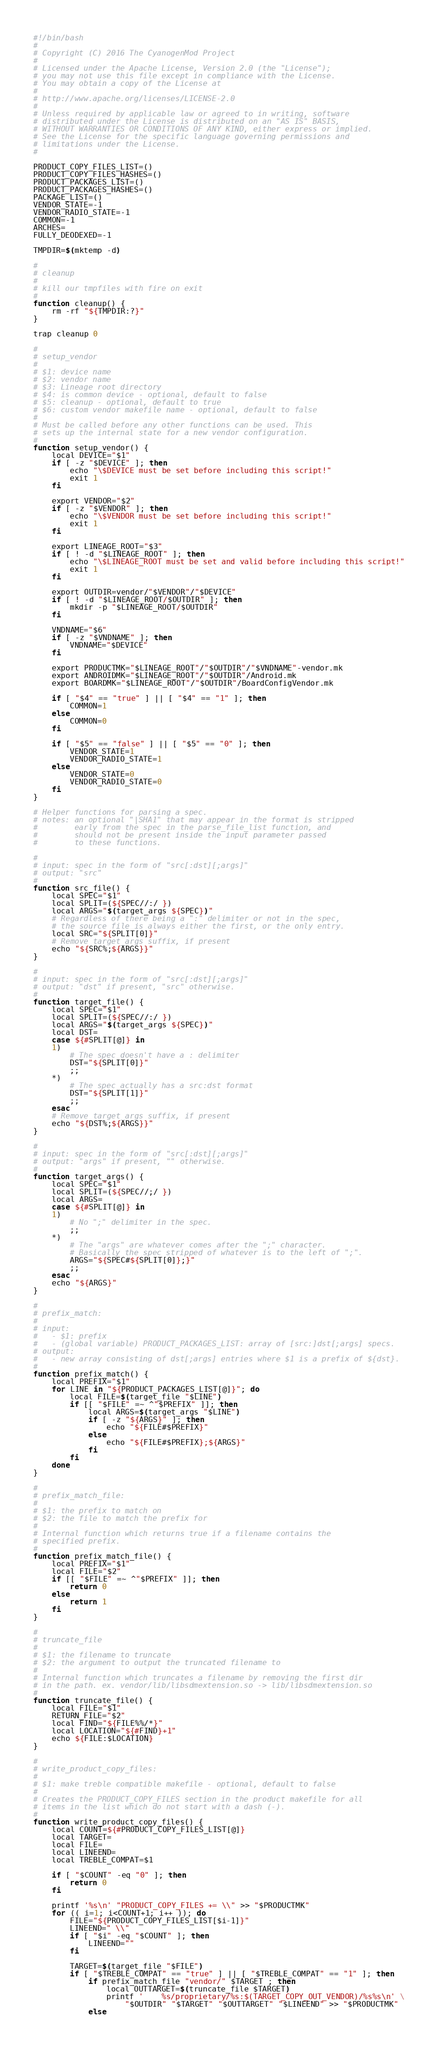<code> <loc_0><loc_0><loc_500><loc_500><_Bash_>#!/bin/bash
#
# Copyright (C) 2016 The CyanogenMod Project
#
# Licensed under the Apache License, Version 2.0 (the "License");
# you may not use this file except in compliance with the License.
# You may obtain a copy of the License at
#
# http://www.apache.org/licenses/LICENSE-2.0
#
# Unless required by applicable law or agreed to in writing, software
# distributed under the License is distributed on an "AS IS" BASIS,
# WITHOUT WARRANTIES OR CONDITIONS OF ANY KIND, either express or implied.
# See the License for the specific language governing permissions and
# limitations under the License.
#

PRODUCT_COPY_FILES_LIST=()
PRODUCT_COPY_FILES_HASHES=()
PRODUCT_PACKAGES_LIST=()
PRODUCT_PACKAGES_HASHES=()
PACKAGE_LIST=()
VENDOR_STATE=-1
VENDOR_RADIO_STATE=-1
COMMON=-1
ARCHES=
FULLY_DEODEXED=-1

TMPDIR=$(mktemp -d)

#
# cleanup
#
# kill our tmpfiles with fire on exit
#
function cleanup() {
    rm -rf "${TMPDIR:?}"
}

trap cleanup 0

#
# setup_vendor
#
# $1: device name
# $2: vendor name
# $3: Lineage root directory
# $4: is common device - optional, default to false
# $5: cleanup - optional, default to true
# $6: custom vendor makefile name - optional, default to false
#
# Must be called before any other functions can be used. This
# sets up the internal state for a new vendor configuration.
#
function setup_vendor() {
    local DEVICE="$1"
    if [ -z "$DEVICE" ]; then
        echo "\$DEVICE must be set before including this script!"
        exit 1
    fi

    export VENDOR="$2"
    if [ -z "$VENDOR" ]; then
        echo "\$VENDOR must be set before including this script!"
        exit 1
    fi

    export LINEAGE_ROOT="$3"
    if [ ! -d "$LINEAGE_ROOT" ]; then
        echo "\$LINEAGE_ROOT must be set and valid before including this script!"
        exit 1
    fi

    export OUTDIR=vendor/"$VENDOR"/"$DEVICE"
    if [ ! -d "$LINEAGE_ROOT/$OUTDIR" ]; then
        mkdir -p "$LINEAGE_ROOT/$OUTDIR"
    fi

    VNDNAME="$6"
    if [ -z "$VNDNAME" ]; then
        VNDNAME="$DEVICE"
    fi

    export PRODUCTMK="$LINEAGE_ROOT"/"$OUTDIR"/"$VNDNAME"-vendor.mk
    export ANDROIDMK="$LINEAGE_ROOT"/"$OUTDIR"/Android.mk
    export BOARDMK="$LINEAGE_ROOT"/"$OUTDIR"/BoardConfigVendor.mk

    if [ "$4" == "true" ] || [ "$4" == "1" ]; then
        COMMON=1
    else
        COMMON=0
    fi

    if [ "$5" == "false" ] || [ "$5" == "0" ]; then
        VENDOR_STATE=1
        VENDOR_RADIO_STATE=1
    else
        VENDOR_STATE=0
        VENDOR_RADIO_STATE=0
    fi
}

# Helper functions for parsing a spec.
# notes: an optional "|SHA1" that may appear in the format is stripped
#        early from the spec in the parse_file_list function, and
#        should not be present inside the input parameter passed
#        to these functions.

#
# input: spec in the form of "src[:dst][;args]"
# output: "src"
#
function src_file() {
    local SPEC="$1"
    local SPLIT=(${SPEC//:/ })
    local ARGS="$(target_args ${SPEC})"
    # Regardless of there being a ":" delimiter or not in the spec,
    # the source file is always either the first, or the only entry.
    local SRC="${SPLIT[0]}"
    # Remove target_args suffix, if present
    echo "${SRC%;${ARGS}}"
}

#
# input: spec in the form of "src[:dst][;args]"
# output: "dst" if present, "src" otherwise.
#
function target_file() {
    local SPEC="$1"
    local SPLIT=(${SPEC//:/ })
    local ARGS="$(target_args ${SPEC})"
    local DST=
    case ${#SPLIT[@]} in
    1)
        # The spec doesn't have a : delimiter
        DST="${SPLIT[0]}"
        ;;
    *)
        # The spec actually has a src:dst format
        DST="${SPLIT[1]}"
        ;;
    esac
    # Remove target_args suffix, if present
    echo "${DST%;${ARGS}}"
}

#
# input: spec in the form of "src[:dst][;args]"
# output: "args" if present, "" otherwise.
#
function target_args() {
    local SPEC="$1"
    local SPLIT=(${SPEC//;/ })
    local ARGS=
    case ${#SPLIT[@]} in
    1)
        # No ";" delimiter in the spec.
        ;;
    *)
        # The "args" are whatever comes after the ";" character.
        # Basically the spec stripped of whatever is to the left of ";".
        ARGS="${SPEC#${SPLIT[0]};}"
        ;;
    esac
    echo "${ARGS}"
}

#
# prefix_match:
#
# input:
#   - $1: prefix
#   - (global variable) PRODUCT_PACKAGES_LIST: array of [src:]dst[;args] specs.
# output:
#   - new array consisting of dst[;args] entries where $1 is a prefix of ${dst}.
#
function prefix_match() {
    local PREFIX="$1"
    for LINE in "${PRODUCT_PACKAGES_LIST[@]}"; do
        local FILE=$(target_file "$LINE")
        if [[ "$FILE" =~ ^"$PREFIX" ]]; then
            local ARGS=$(target_args "$LINE")
            if [ -z "${ARGS}" ]; then
                echo "${FILE#$PREFIX}"
            else
                echo "${FILE#$PREFIX};${ARGS}"
            fi
        fi
    done
}

#
# prefix_match_file:
#
# $1: the prefix to match on
# $2: the file to match the prefix for
#
# Internal function which returns true if a filename contains the
# specified prefix.
#
function prefix_match_file() {
    local PREFIX="$1"
    local FILE="$2"
    if [[ "$FILE" =~ ^"$PREFIX" ]]; then
        return 0
    else
        return 1
    fi
}

#
# truncate_file
#
# $1: the filename to truncate
# $2: the argument to output the truncated filename to
#
# Internal function which truncates a filename by removing the first dir
# in the path. ex. vendor/lib/libsdmextension.so -> lib/libsdmextension.so
#
function truncate_file() {
    local FILE="$1"
    RETURN_FILE="$2"
    local FIND="${FILE%%/*}"
    local LOCATION="${#FIND}+1"
    echo ${FILE:$LOCATION}
}

#
# write_product_copy_files:
#
# $1: make treble compatible makefile - optional, default to false
#
# Creates the PRODUCT_COPY_FILES section in the product makefile for all
# items in the list which do not start with a dash (-).
#
function write_product_copy_files() {
    local COUNT=${#PRODUCT_COPY_FILES_LIST[@]}
    local TARGET=
    local FILE=
    local LINEEND=
    local TREBLE_COMPAT=$1

    if [ "$COUNT" -eq "0" ]; then
        return 0
    fi

    printf '%s\n' "PRODUCT_COPY_FILES += \\" >> "$PRODUCTMK"
    for (( i=1; i<COUNT+1; i++ )); do
        FILE="${PRODUCT_COPY_FILES_LIST[$i-1]}"
        LINEEND=" \\"
        if [ "$i" -eq "$COUNT" ]; then
            LINEEND=""
        fi

        TARGET=$(target_file "$FILE")
        if [ "$TREBLE_COMPAT" == "true" ] || [ "$TREBLE_COMPAT" == "1" ]; then
            if prefix_match_file "vendor/" $TARGET ; then
                local OUTTARGET=$(truncate_file $TARGET)
                printf '    %s/proprietary/%s:$(TARGET_COPY_OUT_VENDOR)/%s%s\n' \
                    "$OUTDIR" "$TARGET" "$OUTTARGET" "$LINEEND" >> "$PRODUCTMK"
            else</code> 